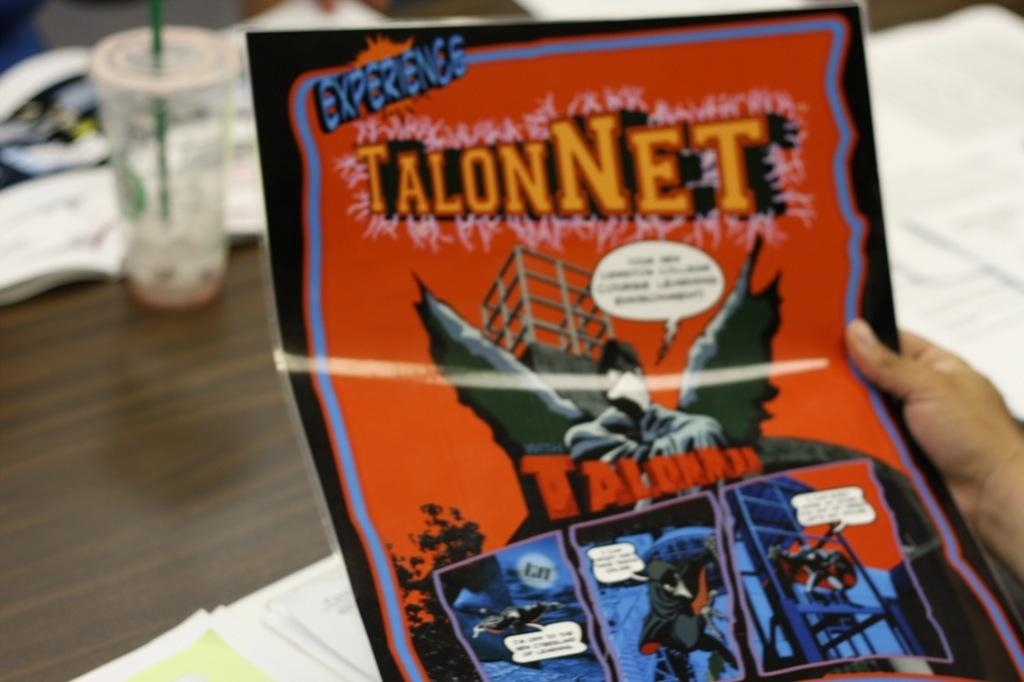<image>
Render a clear and concise summary of the photo. The TalonNet comic book is not from the Marvel Comics brand. 